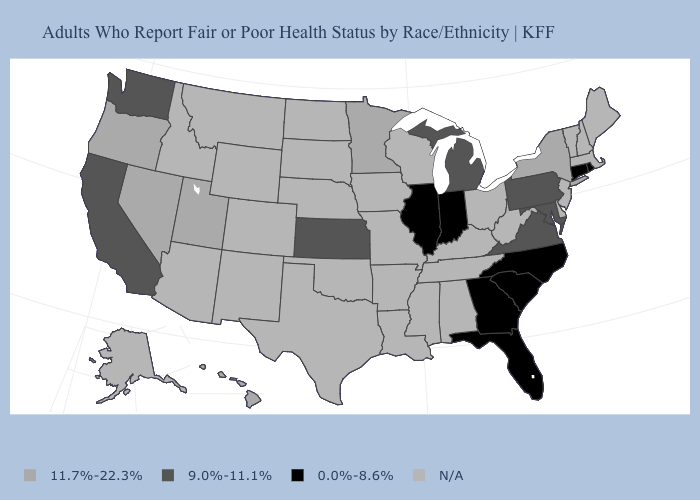Name the states that have a value in the range 0.0%-8.6%?
Concise answer only. Connecticut, Florida, Georgia, Illinois, Indiana, North Carolina, Rhode Island, South Carolina. Does Minnesota have the highest value in the USA?
Short answer required. Yes. What is the value of Wyoming?
Give a very brief answer. N/A. Name the states that have a value in the range N/A?
Answer briefly. Alabama, Alaska, Arizona, Arkansas, Colorado, Delaware, Idaho, Iowa, Kentucky, Louisiana, Maine, Massachusetts, Mississippi, Missouri, Montana, Nebraska, New Hampshire, New Jersey, New Mexico, North Dakota, Ohio, Oklahoma, South Dakota, Tennessee, Texas, Vermont, West Virginia, Wisconsin, Wyoming. Which states have the highest value in the USA?
Concise answer only. Hawaii, Minnesota, Nevada, New York, Oregon, Utah. What is the value of South Carolina?
Give a very brief answer. 0.0%-8.6%. What is the value of North Dakota?
Answer briefly. N/A. Name the states that have a value in the range 11.7%-22.3%?
Short answer required. Hawaii, Minnesota, Nevada, New York, Oregon, Utah. Name the states that have a value in the range 11.7%-22.3%?
Concise answer only. Hawaii, Minnesota, Nevada, New York, Oregon, Utah. What is the value of South Carolina?
Quick response, please. 0.0%-8.6%. Which states have the lowest value in the USA?
Give a very brief answer. Connecticut, Florida, Georgia, Illinois, Indiana, North Carolina, Rhode Island, South Carolina. Which states have the lowest value in the USA?
Keep it brief. Connecticut, Florida, Georgia, Illinois, Indiana, North Carolina, Rhode Island, South Carolina. 